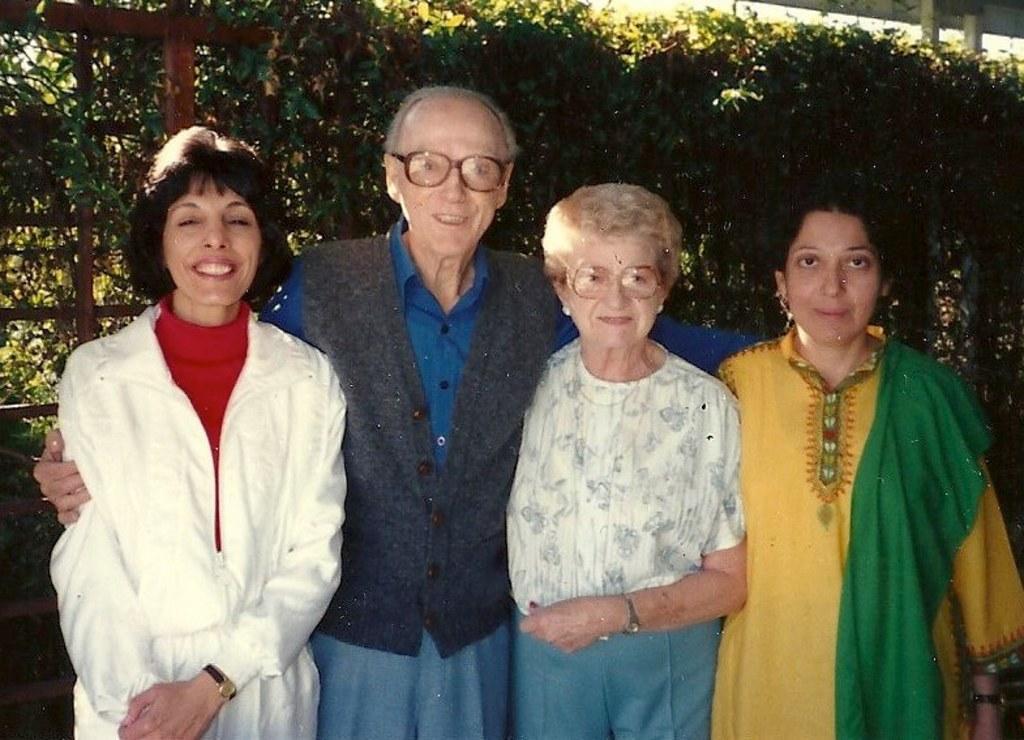Describe this image in one or two sentences. In this picture we can see people and all are smiling. In the background we can see trees. 